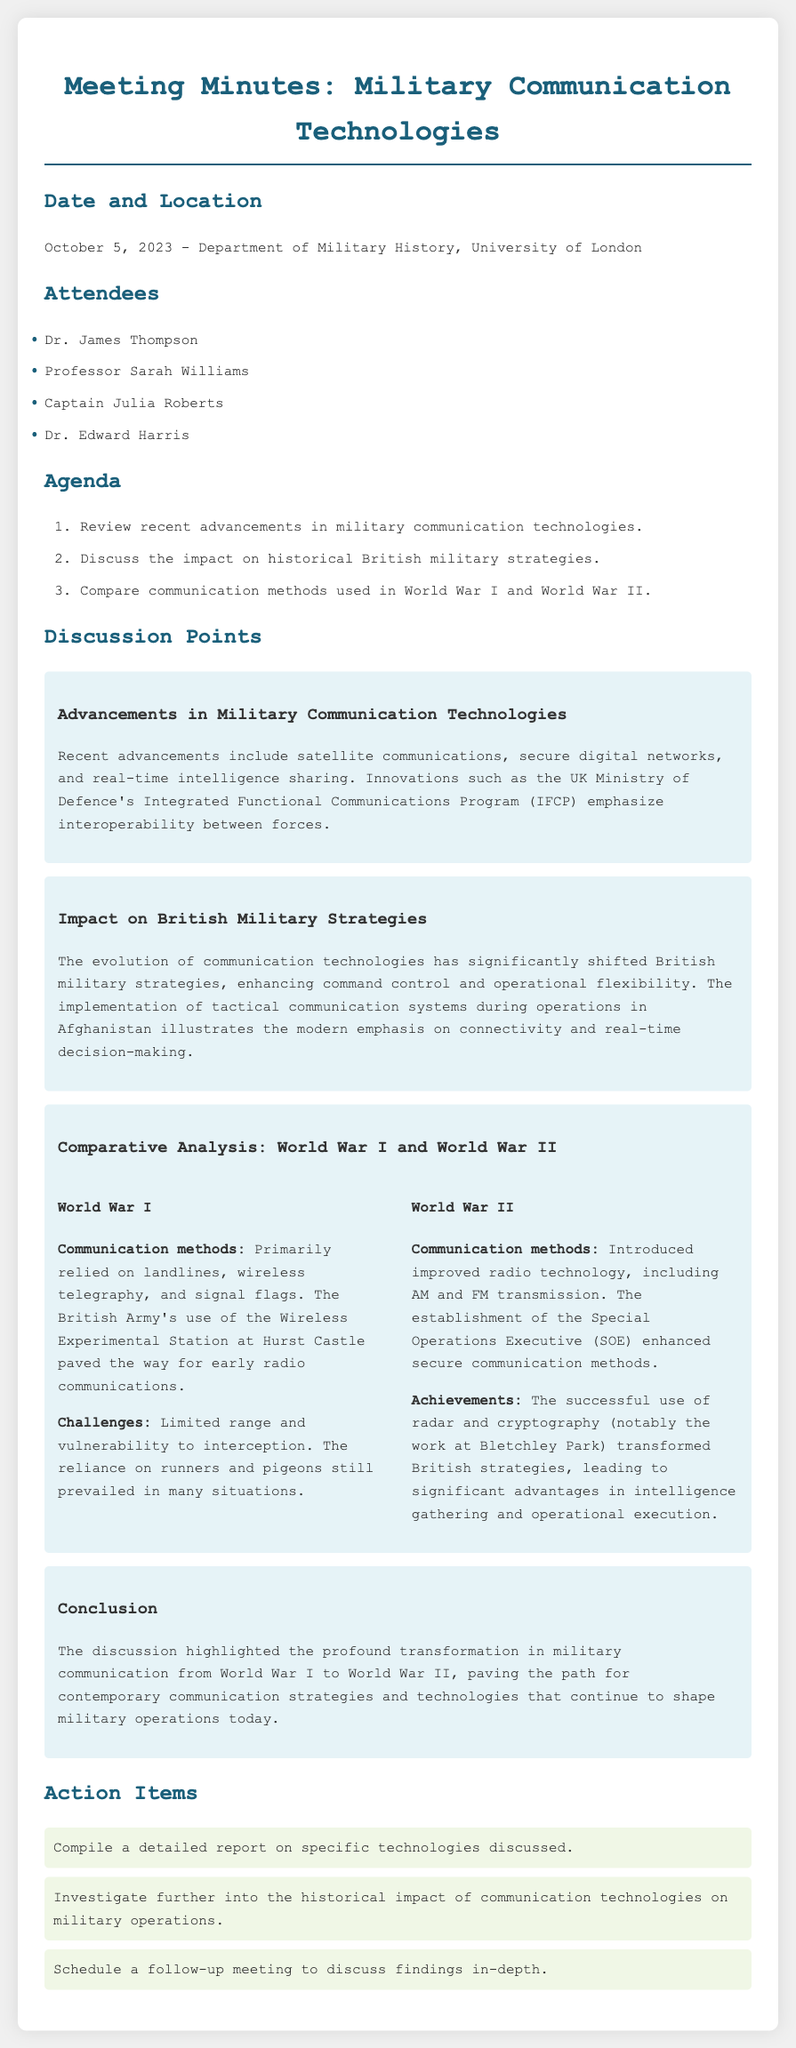What date was the meeting held? The date of the meeting is stated in the document as October 5, 2023.
Answer: October 5, 2023 Who is one of the attendees of the meeting? The document lists several attendees; one example is Dr. James Thompson.
Answer: Dr. James Thompson What innovative program focuses on interoperability? The document mentions the UK Ministry of Defence's Integrated Functional Communications Program (IFCP) as an innovation.
Answer: Integrated Functional Communications Program (IFCP) What communication method was primarily used in World War I? The document indicates that the British Army primarily relied on landlines, wireless telegraphy, and signal flags during World War I.
Answer: Landlines, wireless telegraphy, and signal flags What significant advantage did radar and cryptography provide in World War II? The discussion emphasizes that radar and cryptography, especially the work at Bletchley Park, transformed British strategies, enhancing intelligence gathering.
Answer: Intelligence gathering What action item is listed for the follow-up meeting? The action items include scheduling a follow-up meeting to discuss findings in-depth.
Answer: Schedule a follow-up meeting How did communication technology impact British military strategies? The document states that the evolution of communication technologies greatly shifted British military strategies, enhancing command control and operational flexibility.
Answer: Enhancing command control and operational flexibility Which organization enhanced secure communication methods during World War II? The establishment of the Special Operations Executive (SOE) is mentioned in relation to secure communications.
Answer: Special Operations Executive (SOE) 